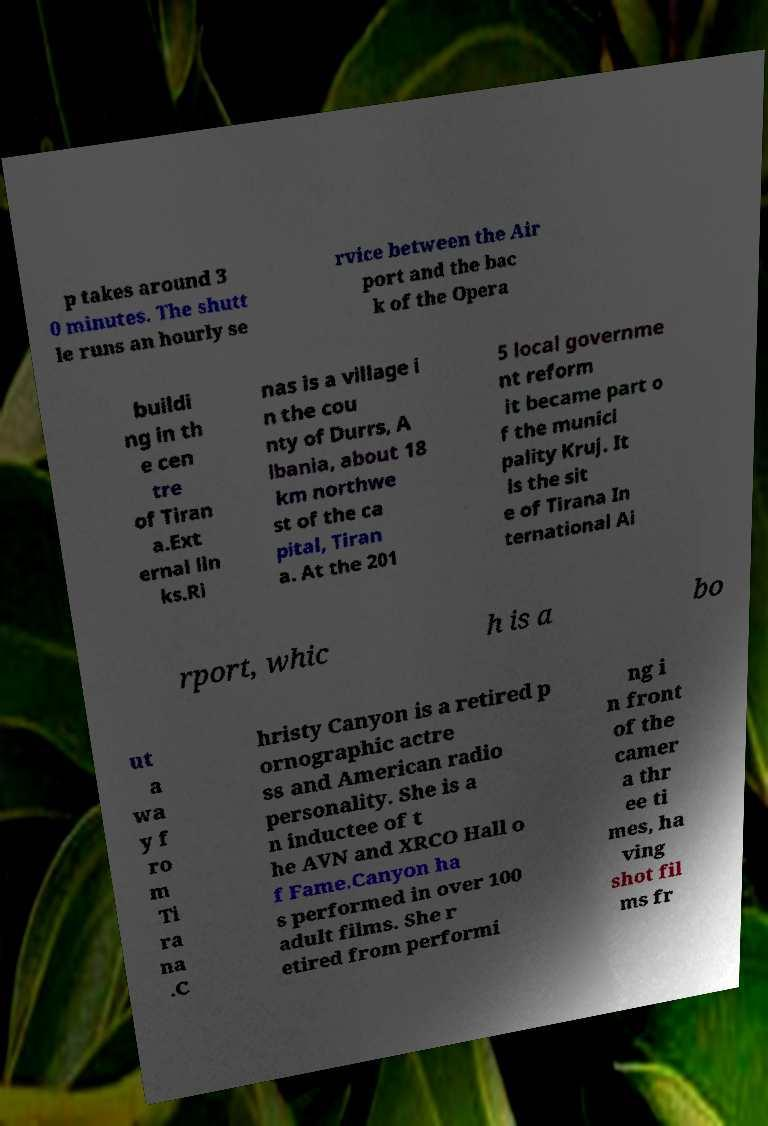What messages or text are displayed in this image? I need them in a readable, typed format. p takes around 3 0 minutes. The shutt le runs an hourly se rvice between the Air port and the bac k of the Opera buildi ng in th e cen tre of Tiran a.Ext ernal lin ks.Ri nas is a village i n the cou nty of Durrs, A lbania, about 18 km northwe st of the ca pital, Tiran a. At the 201 5 local governme nt reform it became part o f the munici pality Kruj. It is the sit e of Tirana In ternational Ai rport, whic h is a bo ut a wa y f ro m Ti ra na .C hristy Canyon is a retired p ornographic actre ss and American radio personality. She is a n inductee of t he AVN and XRCO Hall o f Fame.Canyon ha s performed in over 100 adult films. She r etired from performi ng i n front of the camer a thr ee ti mes, ha ving shot fil ms fr 